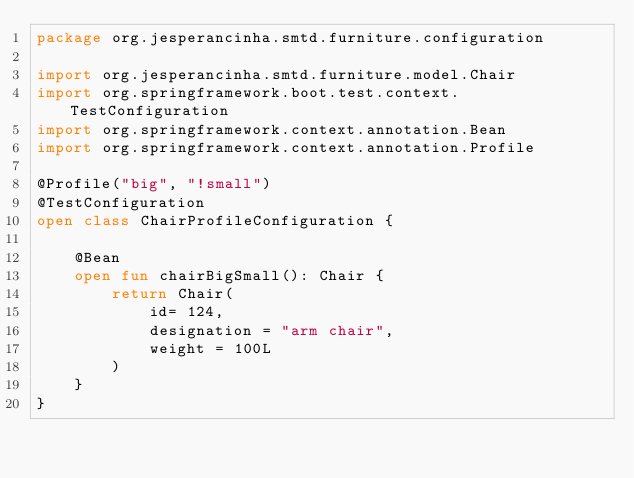Convert code to text. <code><loc_0><loc_0><loc_500><loc_500><_Kotlin_>package org.jesperancinha.smtd.furniture.configuration

import org.jesperancinha.smtd.furniture.model.Chair
import org.springframework.boot.test.context.TestConfiguration
import org.springframework.context.annotation.Bean
import org.springframework.context.annotation.Profile

@Profile("big", "!small")
@TestConfiguration
open class ChairProfileConfiguration {

    @Bean
    open fun chairBigSmall(): Chair {
        return Chair(
            id= 124,
            designation = "arm chair",
            weight = 100L
        )
    }
}

</code> 